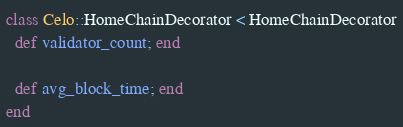<code> <loc_0><loc_0><loc_500><loc_500><_Ruby_>class Celo::HomeChainDecorator < HomeChainDecorator
  def validator_count; end

  def avg_block_time; end
end
</code> 